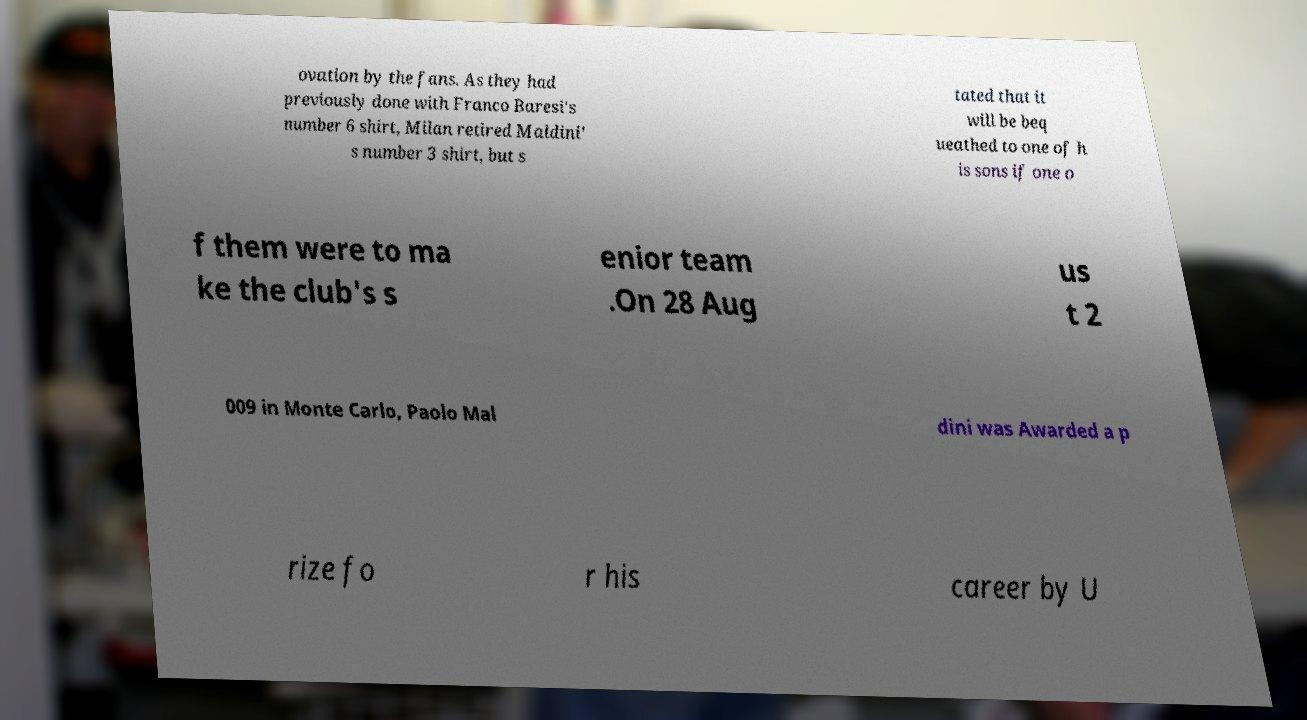Could you extract and type out the text from this image? ovation by the fans. As they had previously done with Franco Baresi's number 6 shirt, Milan retired Maldini' s number 3 shirt, but s tated that it will be beq ueathed to one of h is sons if one o f them were to ma ke the club's s enior team .On 28 Aug us t 2 009 in Monte Carlo, Paolo Mal dini was Awarded a p rize fo r his career by U 